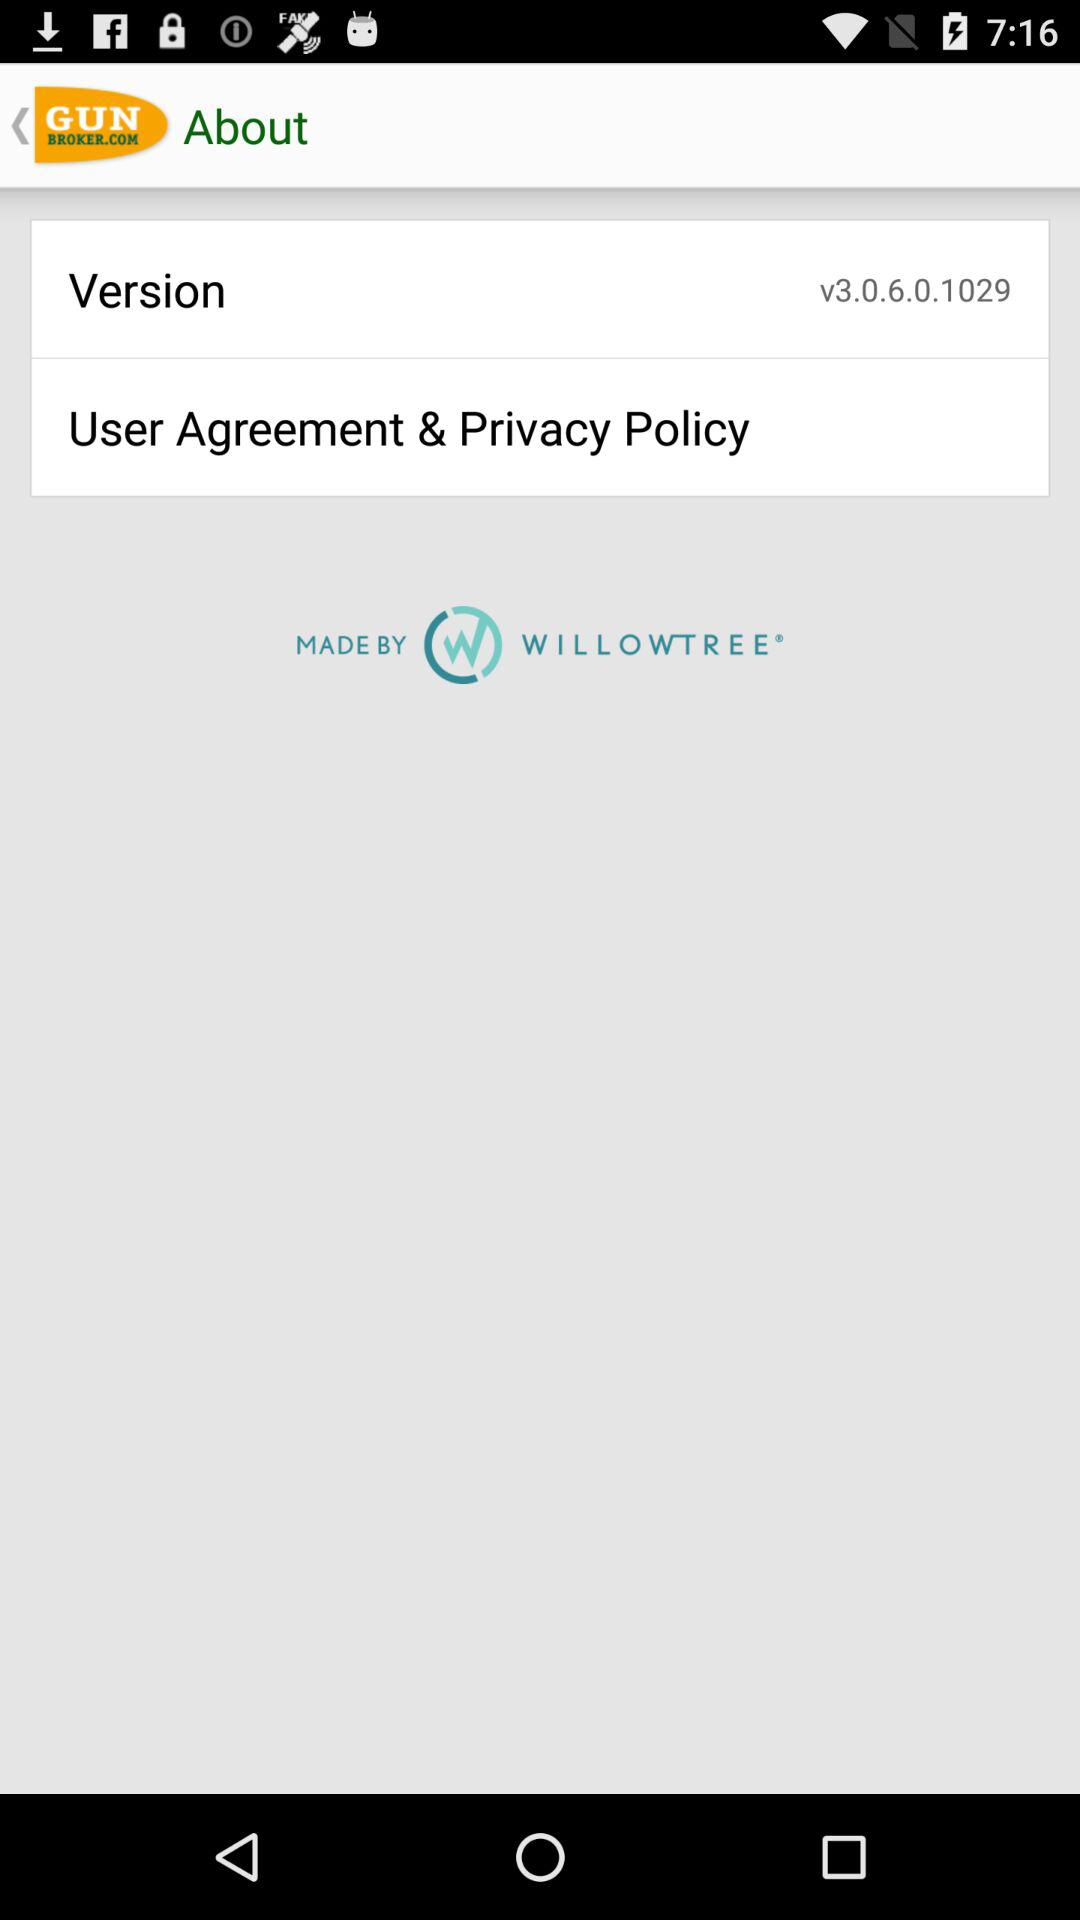What version is used? The version is v3.0.6.0.1029. 